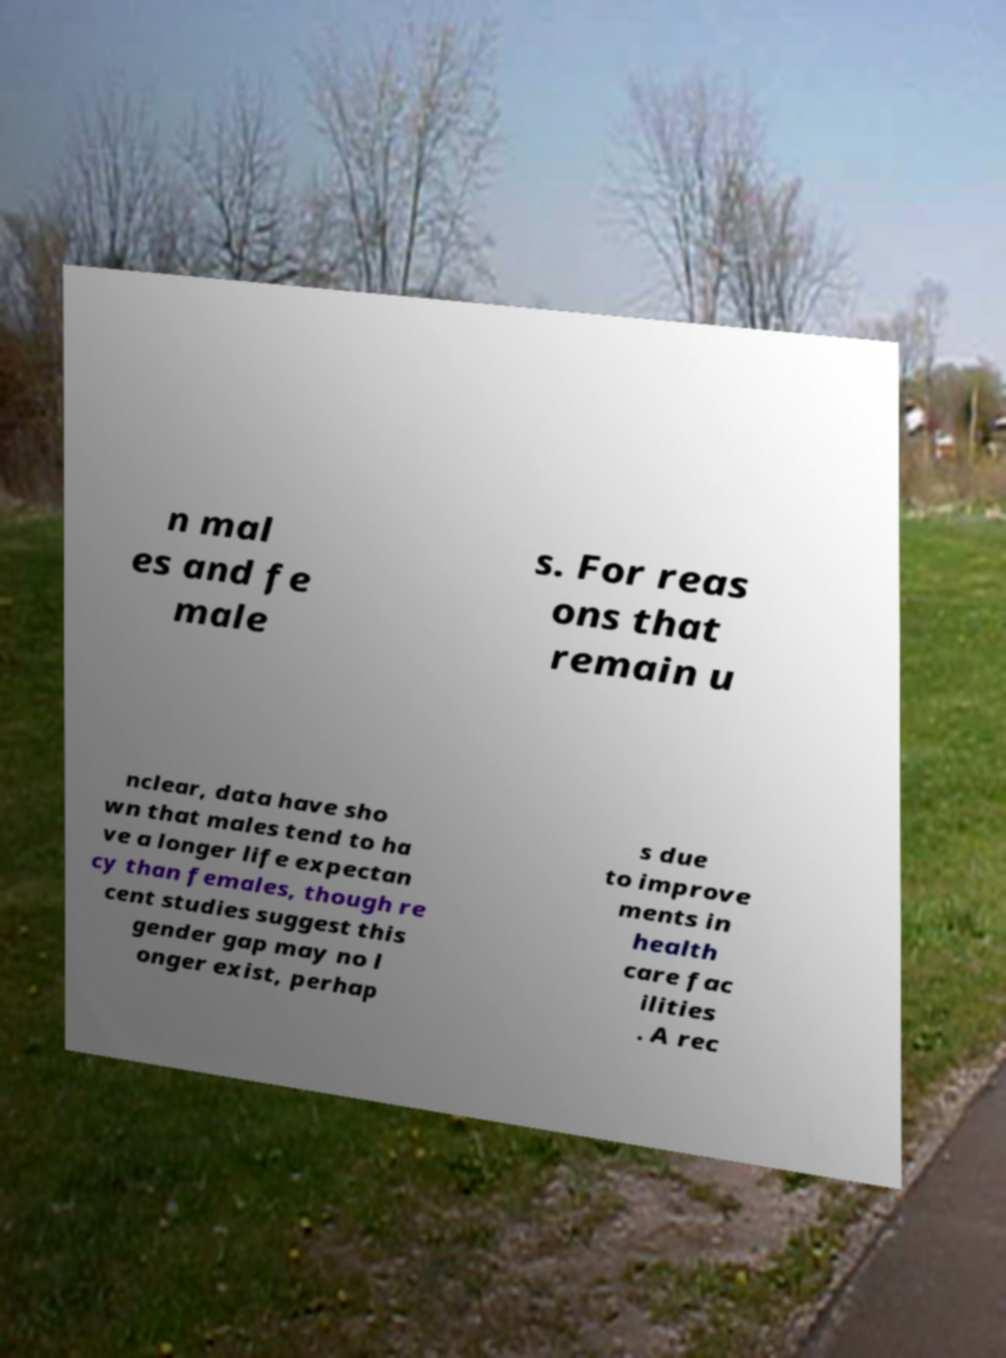I need the written content from this picture converted into text. Can you do that? n mal es and fe male s. For reas ons that remain u nclear, data have sho wn that males tend to ha ve a longer life expectan cy than females, though re cent studies suggest this gender gap may no l onger exist, perhap s due to improve ments in health care fac ilities . A rec 